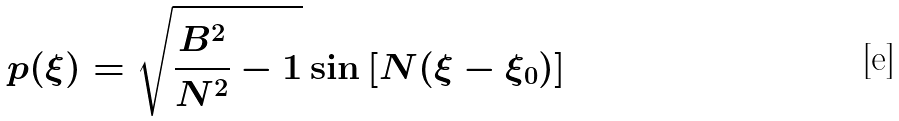<formula> <loc_0><loc_0><loc_500><loc_500>p ( \xi ) = \sqrt { \frac { B ^ { 2 } } { N ^ { 2 } } - 1 } \sin \left [ N ( \xi - \xi _ { 0 } ) \right ]</formula> 